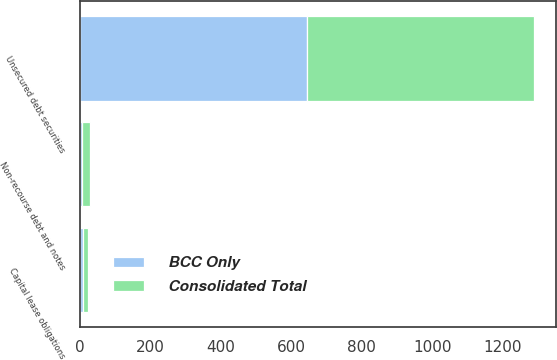Convert chart to OTSL. <chart><loc_0><loc_0><loc_500><loc_500><stacked_bar_chart><ecel><fcel>Unsecured debt securities<fcel>Non-recourse debt and notes<fcel>Capital lease obligations<nl><fcel>Consolidated Total<fcel>644<fcel>24<fcel>14<nl><fcel>BCC Only<fcel>644<fcel>6<fcel>9<nl></chart> 